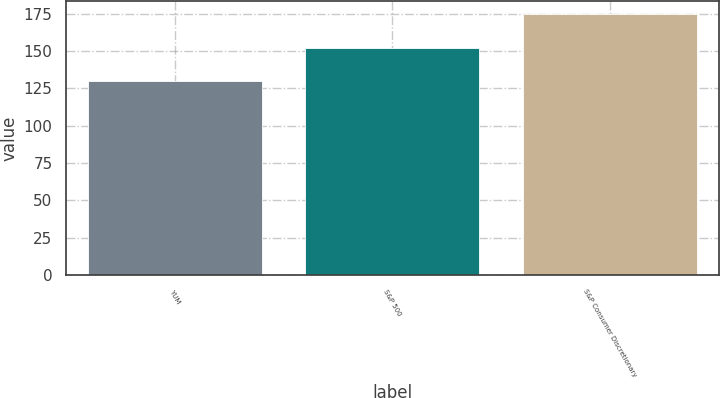Convert chart. <chart><loc_0><loc_0><loc_500><loc_500><bar_chart><fcel>YUM<fcel>S&P 500<fcel>S&P Consumer Discretionary<nl><fcel>130<fcel>152<fcel>175<nl></chart> 